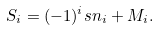<formula> <loc_0><loc_0><loc_500><loc_500>S _ { i } = ( - 1 ) ^ { i } s n _ { i } + M _ { i } .</formula> 